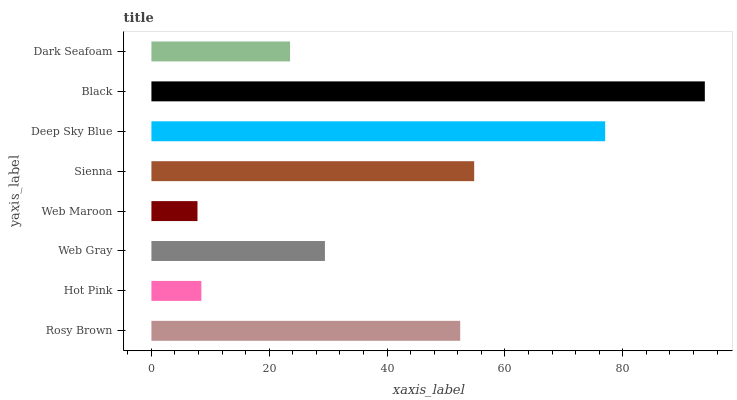Is Web Maroon the minimum?
Answer yes or no. Yes. Is Black the maximum?
Answer yes or no. Yes. Is Hot Pink the minimum?
Answer yes or no. No. Is Hot Pink the maximum?
Answer yes or no. No. Is Rosy Brown greater than Hot Pink?
Answer yes or no. Yes. Is Hot Pink less than Rosy Brown?
Answer yes or no. Yes. Is Hot Pink greater than Rosy Brown?
Answer yes or no. No. Is Rosy Brown less than Hot Pink?
Answer yes or no. No. Is Rosy Brown the high median?
Answer yes or no. Yes. Is Web Gray the low median?
Answer yes or no. Yes. Is Web Maroon the high median?
Answer yes or no. No. Is Black the low median?
Answer yes or no. No. 